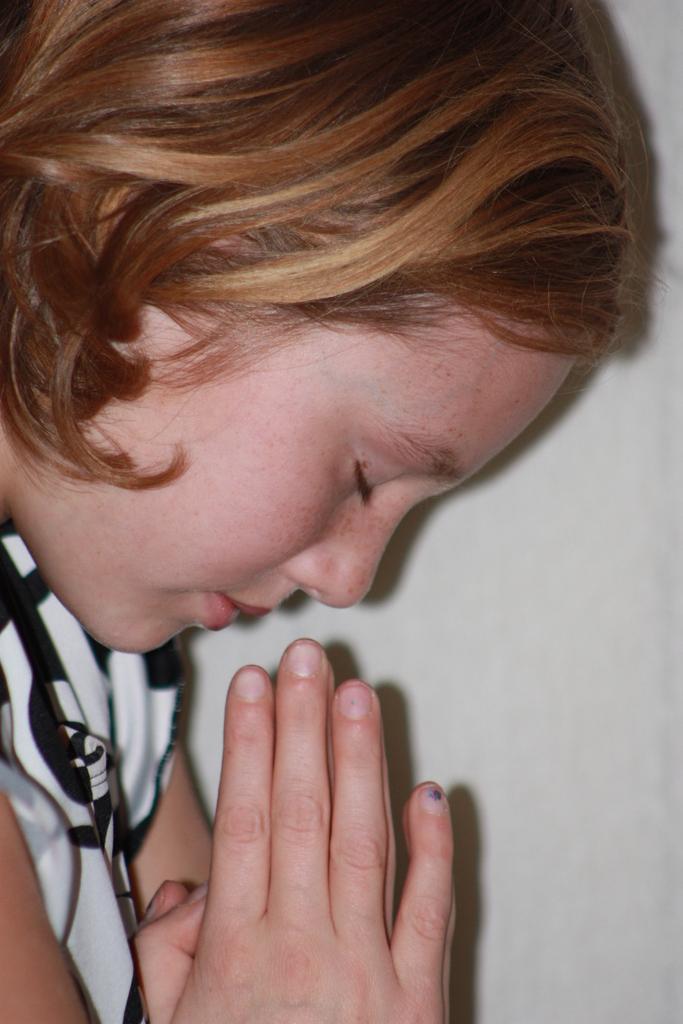How would you summarize this image in a sentence or two? There is a girl praying. In the background we can see wall. 